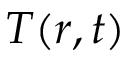Convert formula to latex. <formula><loc_0><loc_0><loc_500><loc_500>T ( r , t )</formula> 